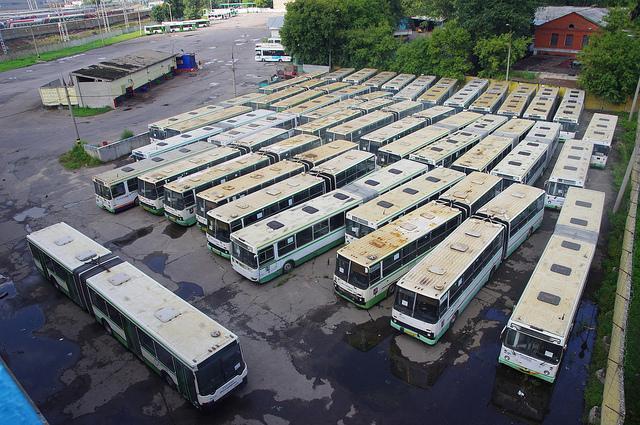What phrase best describes this place?
Pick the correct solution from the four options below to address the question.
Options: Bus depot, circus, football stadium, zoo. Bus depot. 